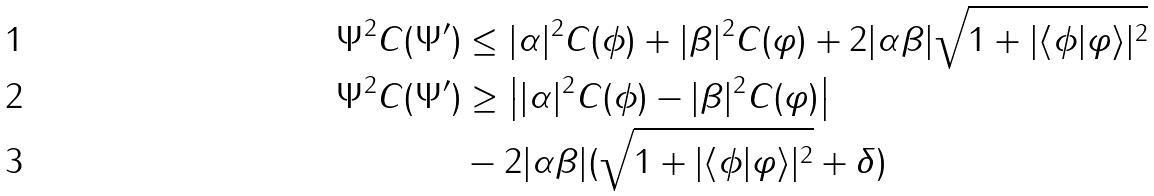<formula> <loc_0><loc_0><loc_500><loc_500>\| \Psi \| ^ { 2 } C ( \Psi ^ { \prime } ) & \leq | \alpha | ^ { 2 } C ( \phi ) + | \beta | ^ { 2 } C ( \varphi ) + 2 | \alpha \beta | \sqrt { 1 + | \langle \phi | \varphi \rangle | ^ { 2 } } \\ \| \Psi \| ^ { 2 } C ( \Psi ^ { \prime } ) & \geq \left | | \alpha | ^ { 2 } C ( \phi ) - | \beta | ^ { 2 } C ( \varphi ) \right | \\ & - 2 | \alpha \beta | ( \sqrt { 1 + | \langle \phi | \varphi \rangle | ^ { 2 } } + \delta )</formula> 